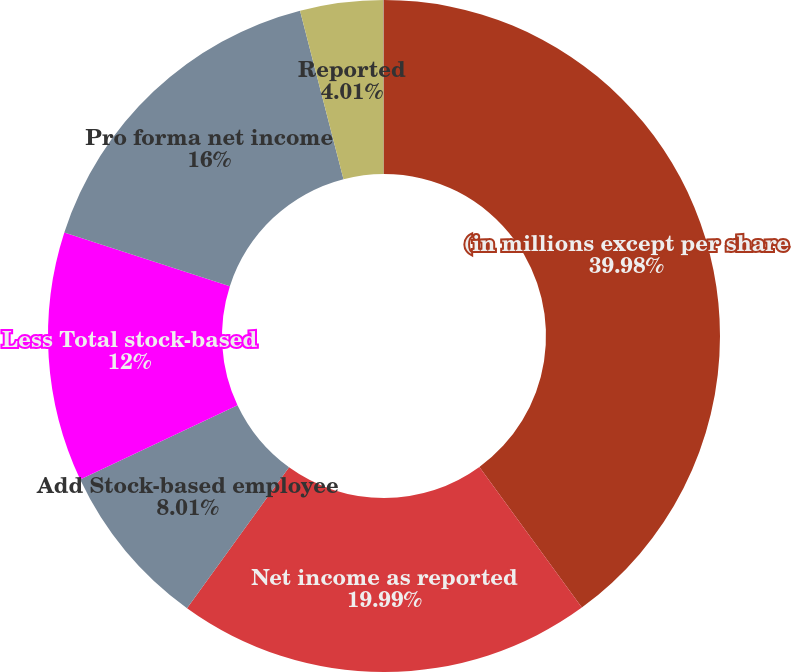<chart> <loc_0><loc_0><loc_500><loc_500><pie_chart><fcel>(in millions except per share<fcel>Net income as reported<fcel>Add Stock-based employee<fcel>Less Total stock-based<fcel>Pro forma net income<fcel>Reported<fcel>Pro forma<nl><fcel>39.98%<fcel>19.99%<fcel>8.01%<fcel>12.0%<fcel>16.0%<fcel>4.01%<fcel>0.01%<nl></chart> 